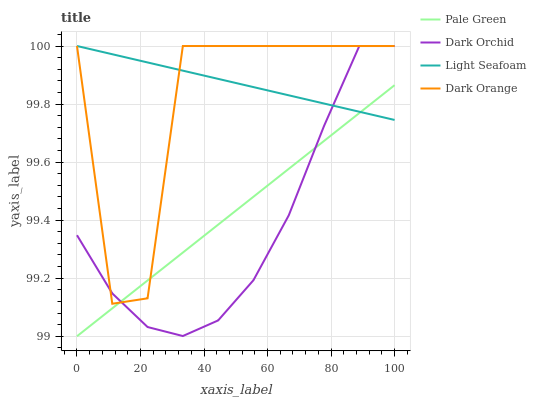Does Dark Orchid have the minimum area under the curve?
Answer yes or no. Yes. Does Light Seafoam have the maximum area under the curve?
Answer yes or no. Yes. Does Dark Orange have the minimum area under the curve?
Answer yes or no. No. Does Dark Orange have the maximum area under the curve?
Answer yes or no. No. Is Pale Green the smoothest?
Answer yes or no. Yes. Is Dark Orange the roughest?
Answer yes or no. Yes. Is Dark Orange the smoothest?
Answer yes or no. No. Is Pale Green the roughest?
Answer yes or no. No. Does Pale Green have the lowest value?
Answer yes or no. Yes. Does Dark Orange have the lowest value?
Answer yes or no. No. Does Dark Orchid have the highest value?
Answer yes or no. Yes. Does Pale Green have the highest value?
Answer yes or no. No. Does Pale Green intersect Dark Orchid?
Answer yes or no. Yes. Is Pale Green less than Dark Orchid?
Answer yes or no. No. Is Pale Green greater than Dark Orchid?
Answer yes or no. No. 